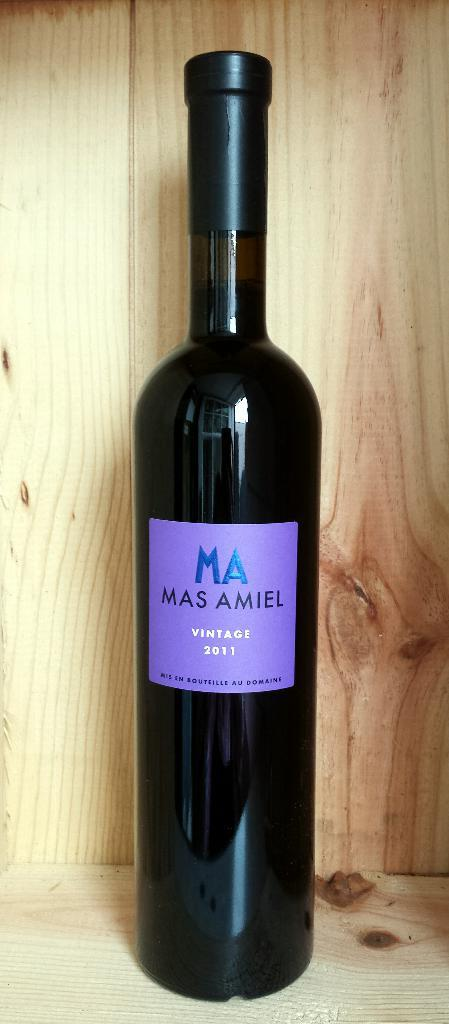<image>
Describe the image concisely. A bottle of Mas Amiel vintage 2011 in a wood box. 